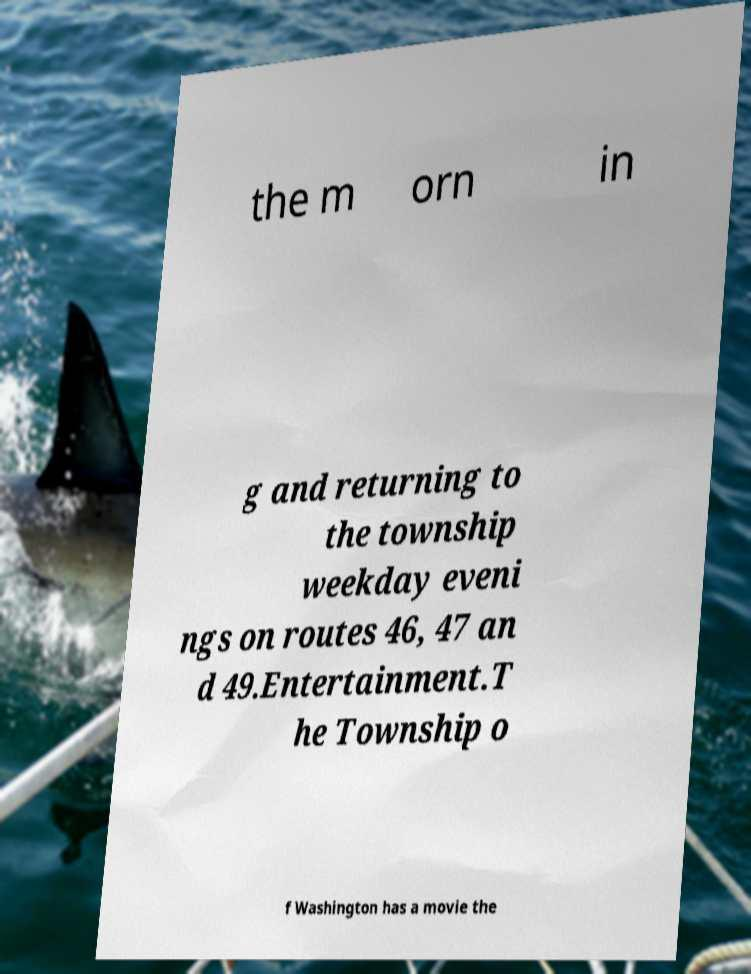Can you read and provide the text displayed in the image?This photo seems to have some interesting text. Can you extract and type it out for me? the m orn in g and returning to the township weekday eveni ngs on routes 46, 47 an d 49.Entertainment.T he Township o f Washington has a movie the 